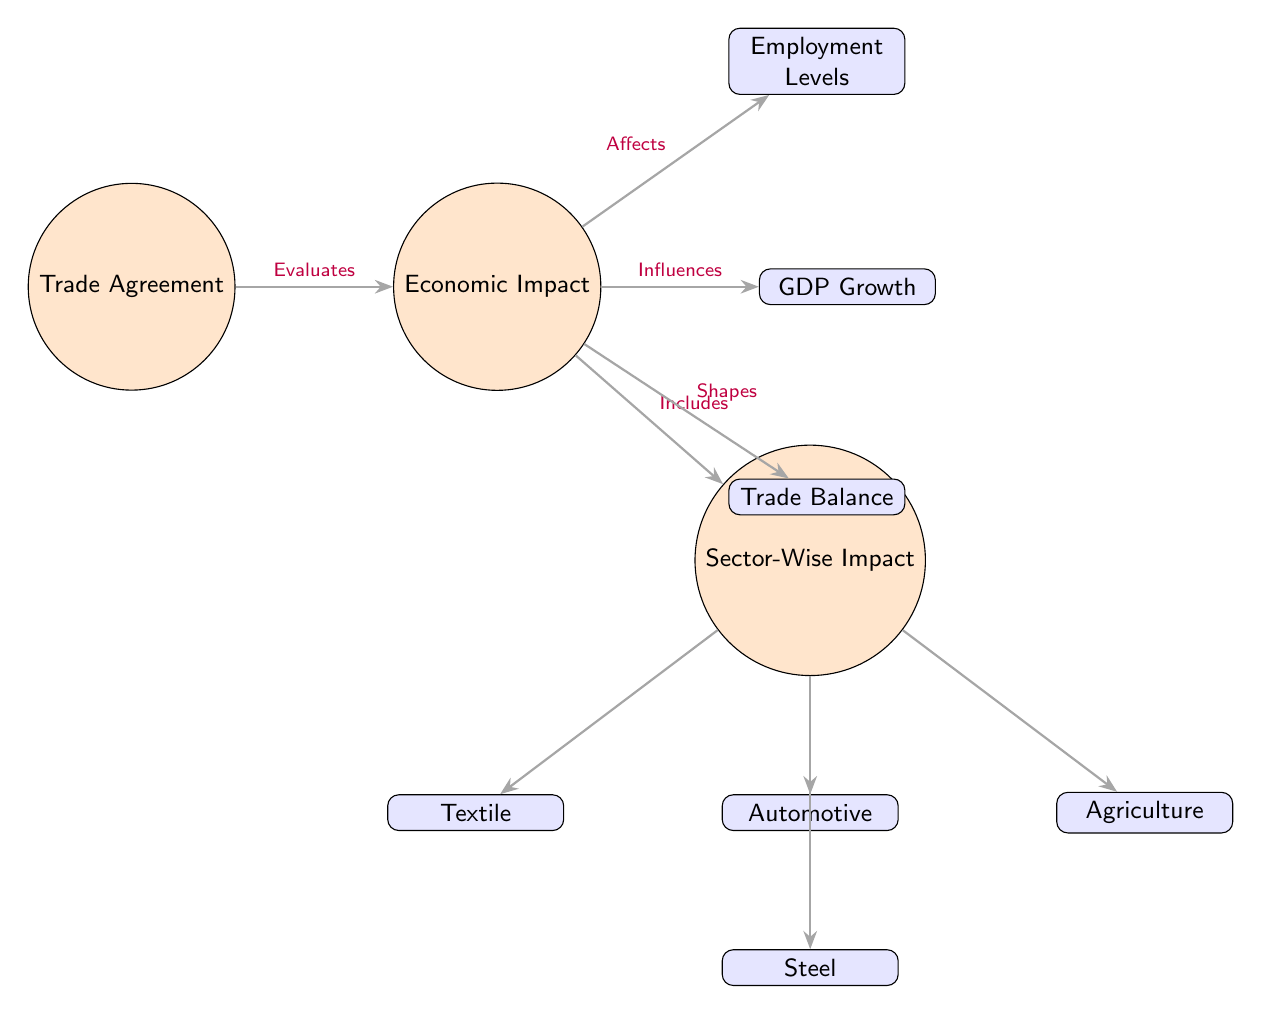What is the main node in the diagram? The main node is labeled "Trade Agreement," which is the starting point of this diagram indicating the focus on examining how trade agreements influence various economic factors.
Answer: Trade Agreement How many sub-nodes does the "Economic Impact" node have? The "Economic Impact" node connects to three sub-nodes: "Employment Levels," "GDP Growth," and "Trade Balance," giving a total of three sub-nodes.
Answer: 3 What does the "Economic Impact" node influence? The "Economic Impact" node influences "Employment Levels," "GDP Growth," and "Trade Balance," demonstrating its effects on these areas after trade agreements are evaluated.
Answer: Employment Levels, GDP Growth, Trade Balance Which sectors are impacted according to the diagram? The sectors impacted are "Automotive," "Textile," "Agriculture," and "Steel," showing how economic impacts affect these specific industries under the trade agreement.
Answer: Automotive, Textile, Agriculture, Steel What relationship exists between "Sector-Wise Impact" and "Economic Impact"? The arrow from "Economic Impact" to "Sector-Wise Impact" labeled "Includes" indicates that "Sector-Wise Impact" is a component of the broader "Economic Impact."
Answer: Includes Which node directly evaluates the trade agreement? The first arrow from "Trade Agreement" to "Economic Impact" labeled "Evaluates" shows that the "Economic Impact" is directly evaluated based on the trade agreement.
Answer: Economic Impact Which sector is located directly below the "Automotive" node? The "Steel" node is located directly below the "Automotive" node, indicating its position within the sector-wise breakdown of impacts.
Answer: Steel What type of impact does the trade agreement evaluate? The trade agreement evaluates "Economic Impact," which is the central focus, encompassing various aspects including sector-wise evaluations as shown in the diagram.
Answer: Economic Impact How many arrows are there pointing from "Economic Impact" node? There are four arrows pointing from the "Economic Impact" node, as it connects to "Employment Levels," "GDP Growth," "Trade Balance," and "Sector-Wise Impact."
Answer: 4 